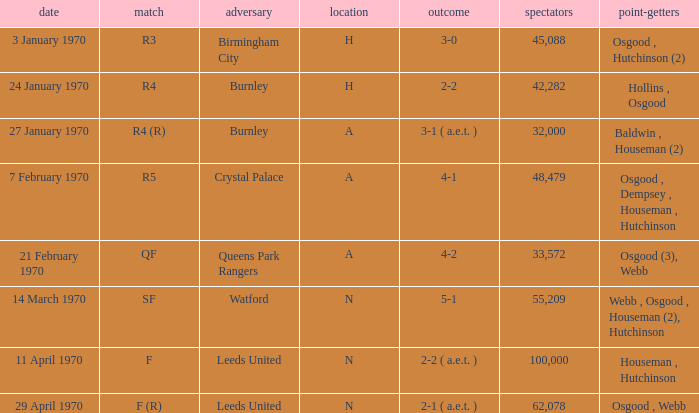When the final score was 5-1, what was the greatest attendance at a game? 55209.0. 